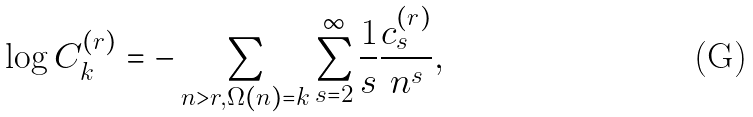<formula> <loc_0><loc_0><loc_500><loc_500>\log C _ { k } ^ { ( r ) } = - \sum _ { n > r , \Omega ( n ) = k } \sum _ { s = 2 } ^ { \infty } \frac { 1 } { s } \frac { c _ { s } ^ { ( r ) } } { n ^ { s } } ,</formula> 